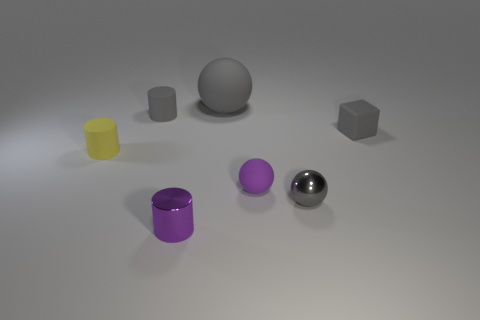Subtract all gray spheres. How many spheres are left? 1 Add 3 rubber things. How many objects exist? 10 Subtract all cylinders. How many objects are left? 4 Add 4 big cyan cylinders. How many big cyan cylinders exist? 4 Subtract 0 brown cylinders. How many objects are left? 7 Subtract all big yellow matte objects. Subtract all tiny metallic objects. How many objects are left? 5 Add 4 purple matte spheres. How many purple matte spheres are left? 5 